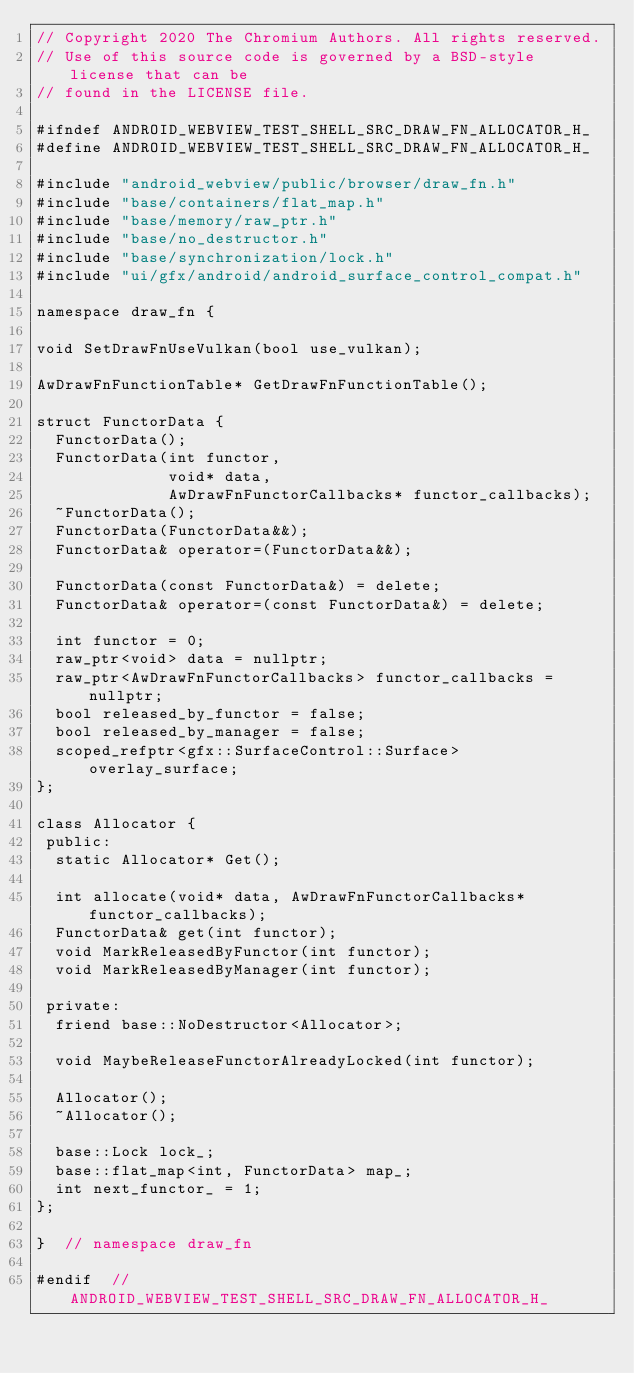Convert code to text. <code><loc_0><loc_0><loc_500><loc_500><_C_>// Copyright 2020 The Chromium Authors. All rights reserved.
// Use of this source code is governed by a BSD-style license that can be
// found in the LICENSE file.

#ifndef ANDROID_WEBVIEW_TEST_SHELL_SRC_DRAW_FN_ALLOCATOR_H_
#define ANDROID_WEBVIEW_TEST_SHELL_SRC_DRAW_FN_ALLOCATOR_H_

#include "android_webview/public/browser/draw_fn.h"
#include "base/containers/flat_map.h"
#include "base/memory/raw_ptr.h"
#include "base/no_destructor.h"
#include "base/synchronization/lock.h"
#include "ui/gfx/android/android_surface_control_compat.h"

namespace draw_fn {

void SetDrawFnUseVulkan(bool use_vulkan);

AwDrawFnFunctionTable* GetDrawFnFunctionTable();

struct FunctorData {
  FunctorData();
  FunctorData(int functor,
              void* data,
              AwDrawFnFunctorCallbacks* functor_callbacks);
  ~FunctorData();
  FunctorData(FunctorData&&);
  FunctorData& operator=(FunctorData&&);

  FunctorData(const FunctorData&) = delete;
  FunctorData& operator=(const FunctorData&) = delete;

  int functor = 0;
  raw_ptr<void> data = nullptr;
  raw_ptr<AwDrawFnFunctorCallbacks> functor_callbacks = nullptr;
  bool released_by_functor = false;
  bool released_by_manager = false;
  scoped_refptr<gfx::SurfaceControl::Surface> overlay_surface;
};

class Allocator {
 public:
  static Allocator* Get();

  int allocate(void* data, AwDrawFnFunctorCallbacks* functor_callbacks);
  FunctorData& get(int functor);
  void MarkReleasedByFunctor(int functor);
  void MarkReleasedByManager(int functor);

 private:
  friend base::NoDestructor<Allocator>;

  void MaybeReleaseFunctorAlreadyLocked(int functor);

  Allocator();
  ~Allocator();

  base::Lock lock_;
  base::flat_map<int, FunctorData> map_;
  int next_functor_ = 1;
};

}  // namespace draw_fn

#endif  // ANDROID_WEBVIEW_TEST_SHELL_SRC_DRAW_FN_ALLOCATOR_H_
</code> 